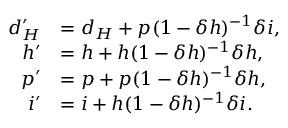<formula> <loc_0><loc_0><loc_500><loc_500>\begin{array} { r l } { d _ { H } ^ { \prime } } & { = d _ { H } + p ( 1 - \delta h ) ^ { - 1 } \delta i , } \\ { h ^ { \prime } } & { = h + h ( 1 - \delta h ) ^ { - 1 } \delta h , } \\ { p ^ { \prime } } & { = p + p ( 1 - \delta h ) ^ { - 1 } \delta h , } \\ { i ^ { \prime } } & { = i + h ( 1 - \delta h ) ^ { - 1 } \delta i . } \end{array}</formula> 